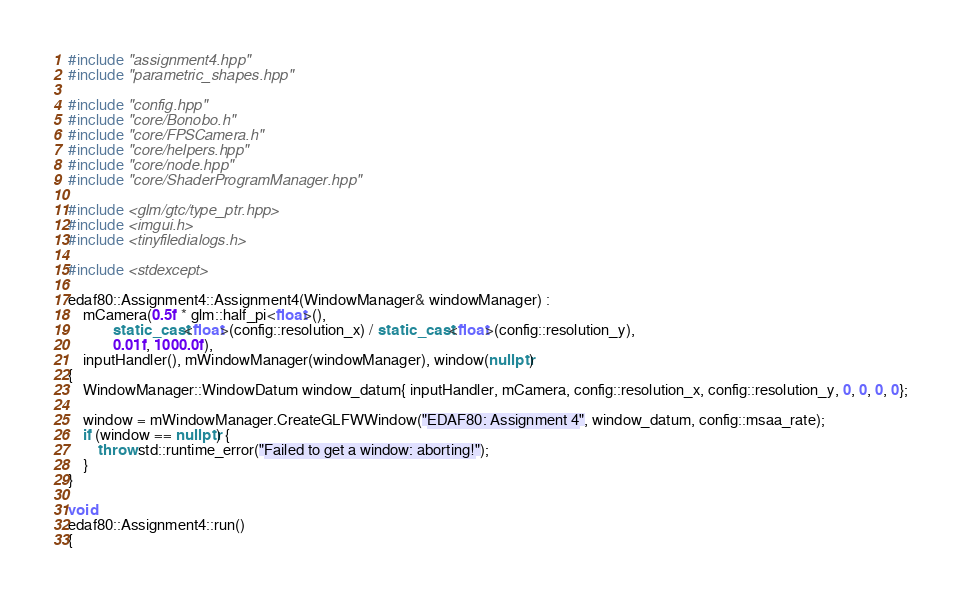Convert code to text. <code><loc_0><loc_0><loc_500><loc_500><_C++_>#include "assignment4.hpp"
#include "parametric_shapes.hpp"

#include "config.hpp"
#include "core/Bonobo.h"
#include "core/FPSCamera.h"
#include "core/helpers.hpp"
#include "core/node.hpp"
#include "core/ShaderProgramManager.hpp"

#include <glm/gtc/type_ptr.hpp>
#include <imgui.h>
#include <tinyfiledialogs.h>

#include <stdexcept>

edaf80::Assignment4::Assignment4(WindowManager& windowManager) :
	mCamera(0.5f * glm::half_pi<float>(),
	        static_cast<float>(config::resolution_x) / static_cast<float>(config::resolution_y),
	        0.01f, 1000.0f),
	inputHandler(), mWindowManager(windowManager), window(nullptr)
{
	WindowManager::WindowDatum window_datum{ inputHandler, mCamera, config::resolution_x, config::resolution_y, 0, 0, 0, 0};

	window = mWindowManager.CreateGLFWWindow("EDAF80: Assignment 4", window_datum, config::msaa_rate);
	if (window == nullptr) {
		throw std::runtime_error("Failed to get a window: aborting!");
	}
}

void
edaf80::Assignment4::run()
{</code> 